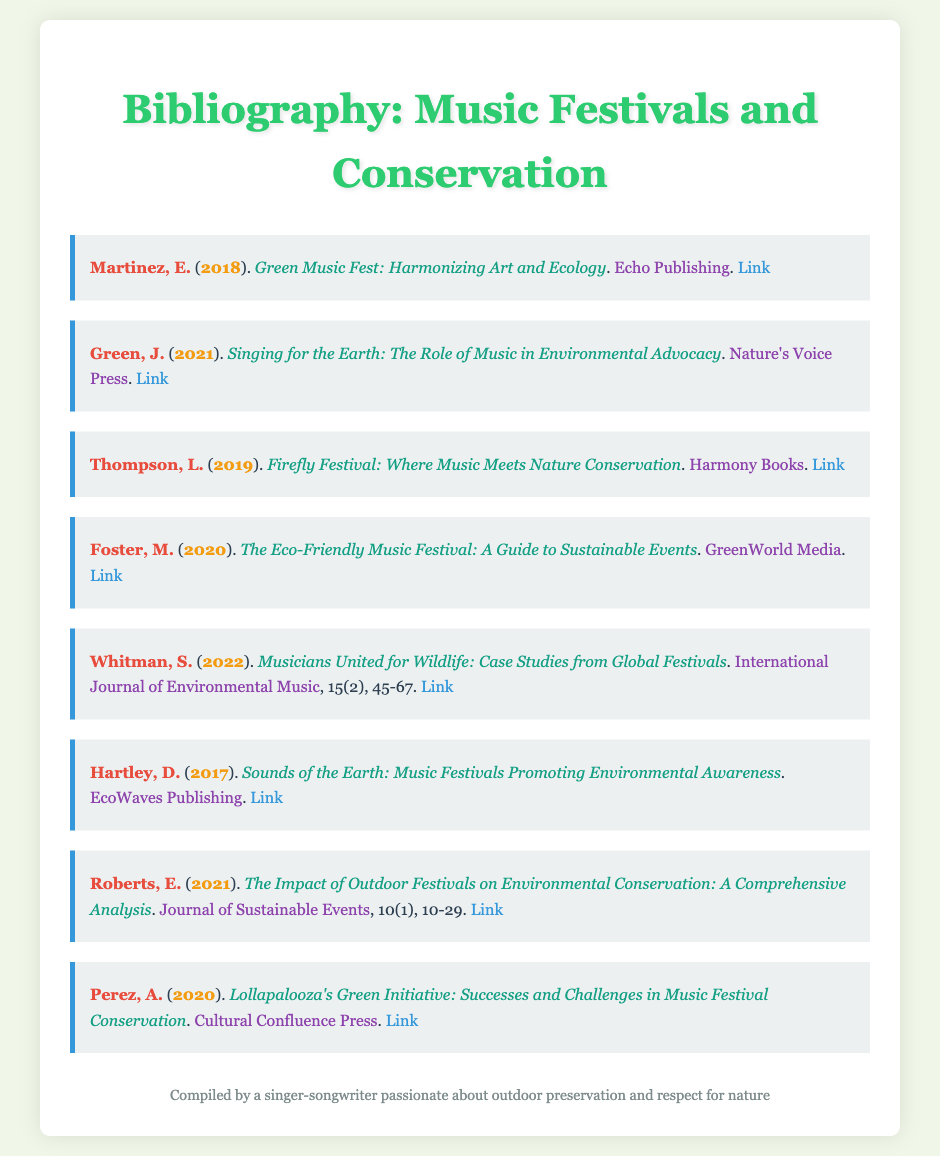What is the title of the book by Martinez? The title of the book by Martinez is found in the bibliography's entry for him, which reads: "Green Music Fest: Harmonizing Art and Ecology."
Answer: Green Music Fest: Harmonizing Art and Ecology Who published "Singing for the Earth"? The publisher is mentioned in the bibliography entry for Green, indicating who produced the book "Singing for the Earth."
Answer: Nature's Voice Press What year was "The Eco-Friendly Music Festival" published? The year is specifically stated in the bibliography entry for Foster regarding when the book was released.
Answer: 2020 Which journal includes the article by Whitman? The journal where Whitman's article is published is noted in the citation detail, identifying the source of the article.
Answer: International Journal of Environmental Music What is the main focus of the book by Hartley? The focus is derived from the title of Hartley's book, which emphasizes the theme of environmental awareness in music festivals.
Answer: Music Festivals Promoting Environmental Awareness What common theme do most of the works in this bibliography share? By analyzing the titles and authors, it becomes apparent that the overarching theme is related to conservation and environmental advocacy through music events.
Answer: Conservation and Environmental Advocacy How many entries are in the bibliography? The count of entries is deduced by counting the different bibliography items presented in the document.
Answer: Eight What type of publication is "The Impact of Outdoor Festivals on Environmental Conservation"? The type of publication can be inferred from the citation format, distinguishing it from books and indicating it is part of a journal.
Answer: Journal 